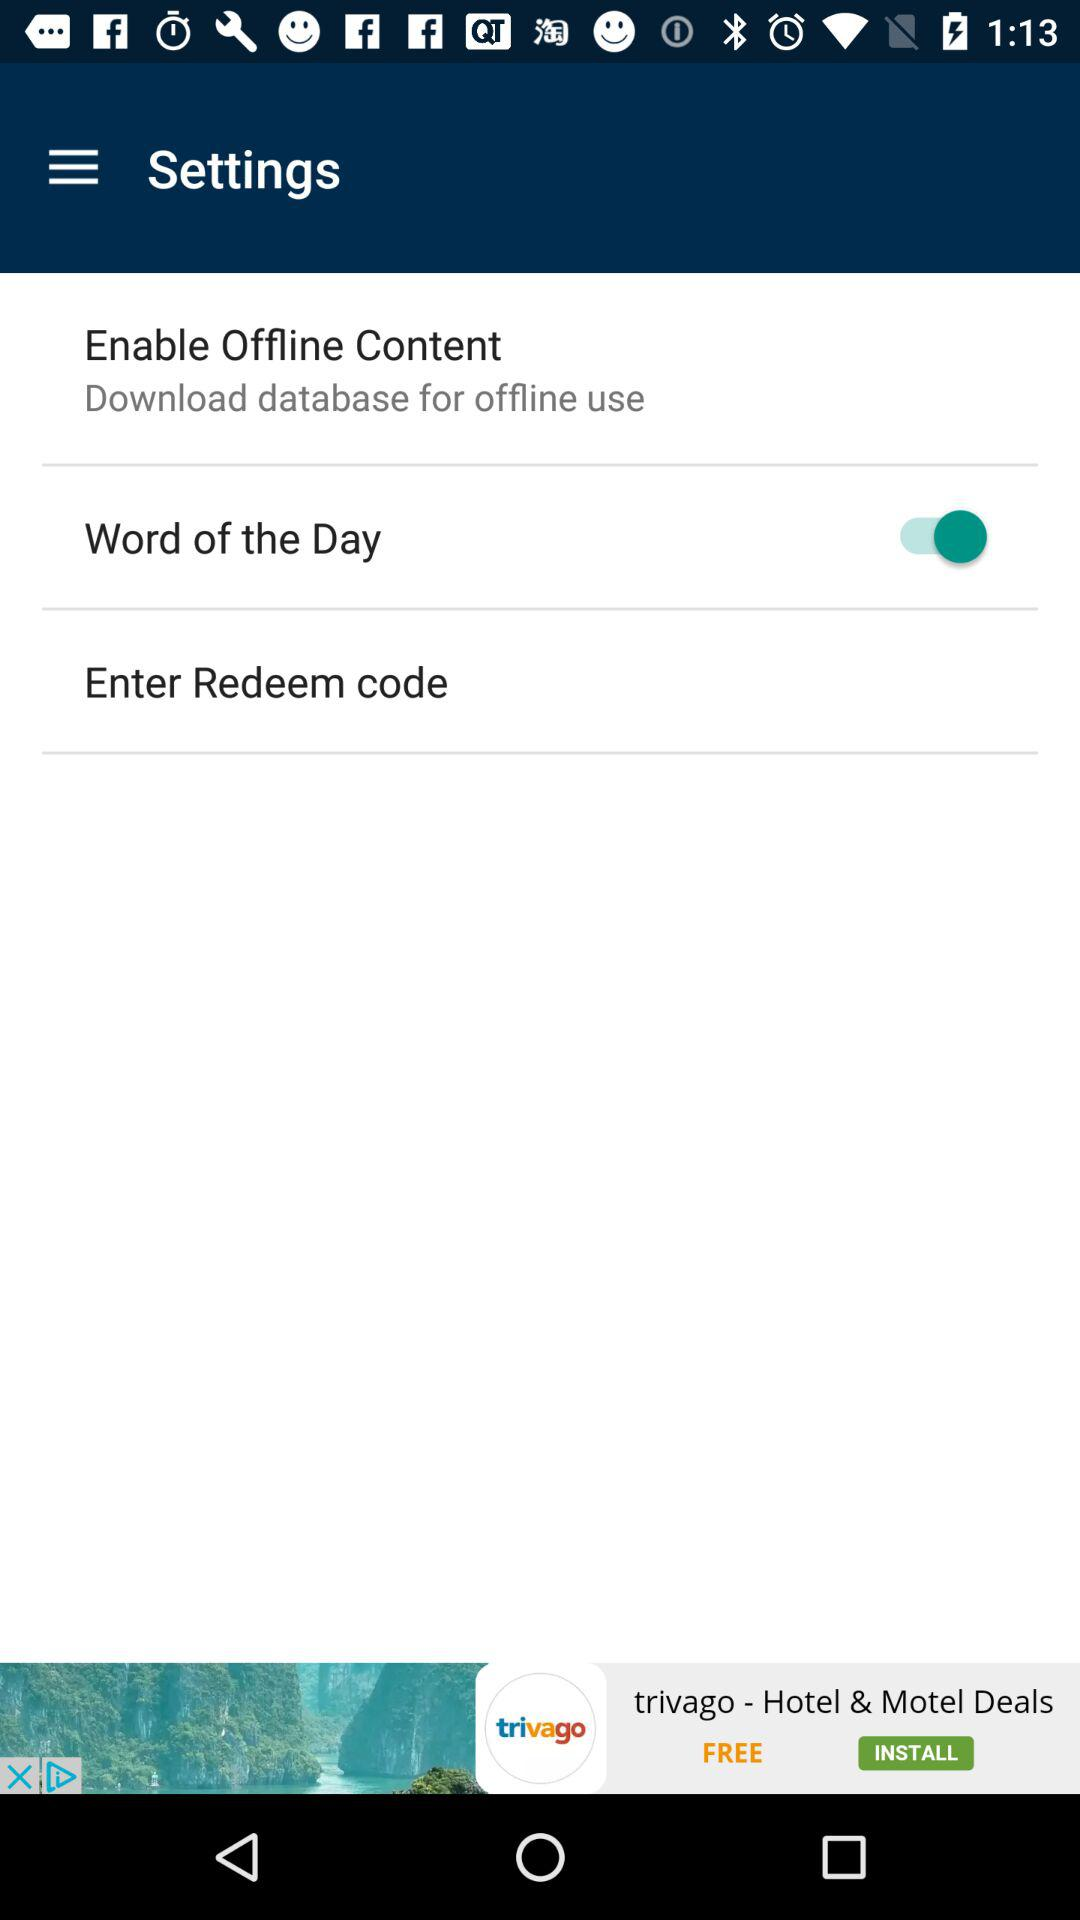What is the status of "Word of the Day"? The status is "on". 